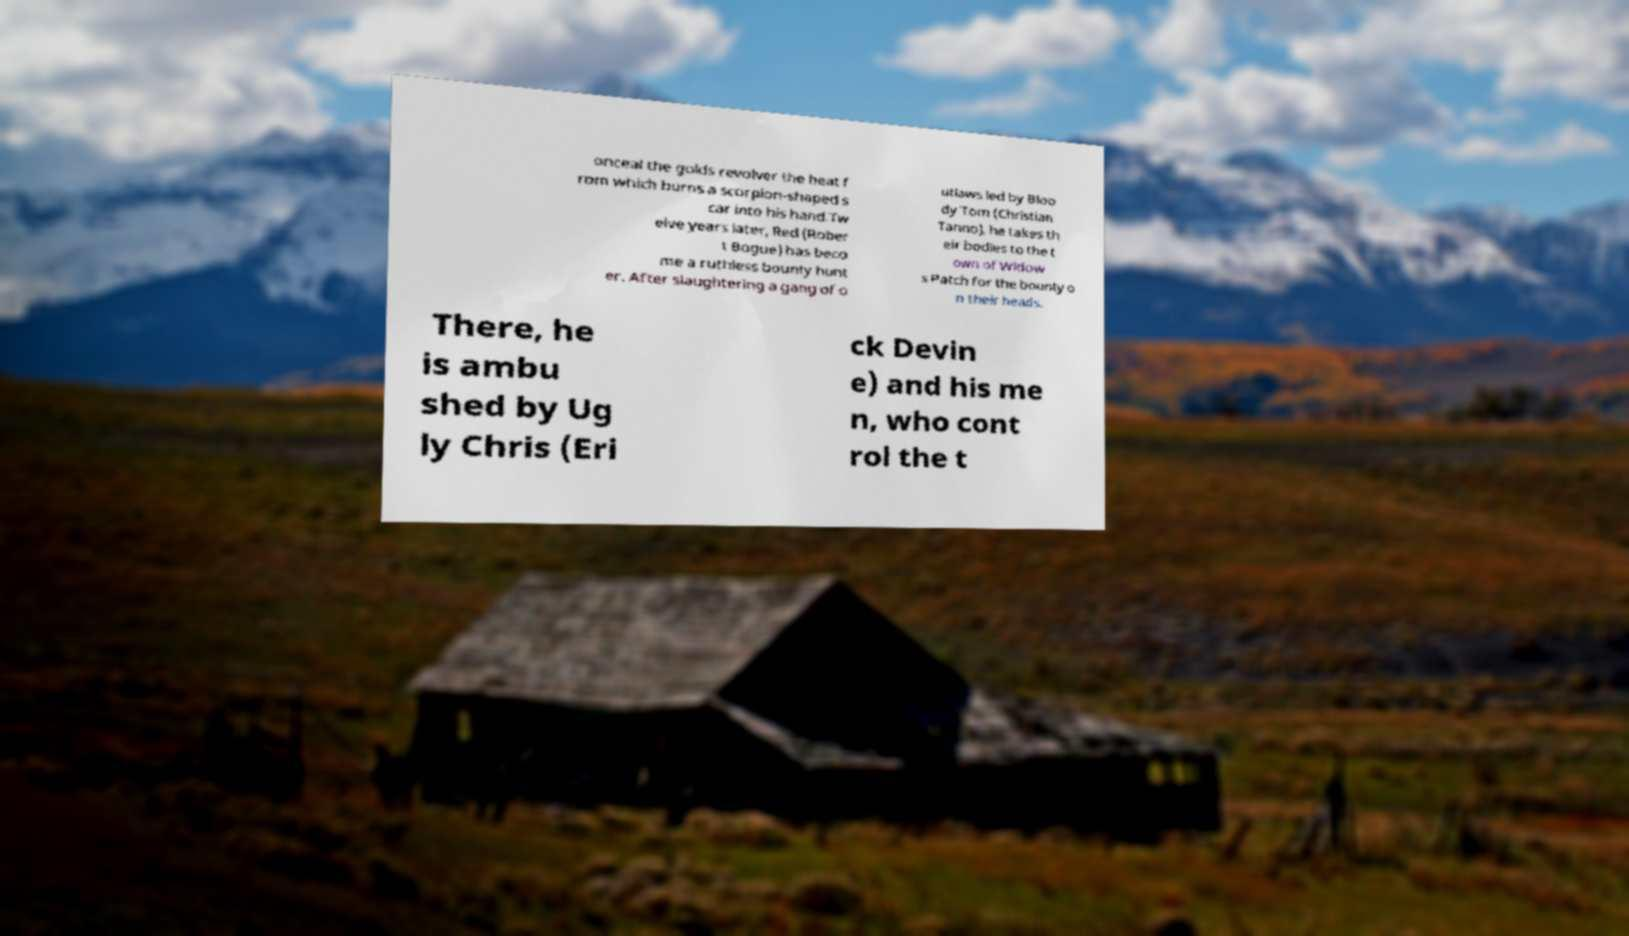Can you read and provide the text displayed in the image?This photo seems to have some interesting text. Can you extract and type it out for me? onceal the golds revolver the heat f rom which burns a scorpion-shaped s car into his hand.Tw elve years later, Red (Rober t Bogue) has beco me a ruthless bounty hunt er. After slaughtering a gang of o utlaws led by Bloo dy Tom (Christian Tanno), he takes th eir bodies to the t own of Widow s Patch for the bounty o n their heads. There, he is ambu shed by Ug ly Chris (Eri ck Devin e) and his me n, who cont rol the t 